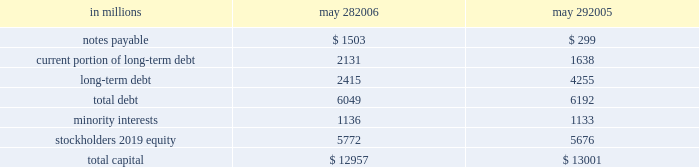During fiscal 2006 , we repurchased 19 million shares of common stock for an aggregate purchase price of $ 892 million , of which $ 7 million settled after the end of our fiscal year .
In fiscal 2005 , we repurchased 17 million shares of common stock for an aggregate purchase price of $ 771 million .
A total of 146 million shares were held in treasury at may 28 , 2006 .
We also used cash from operations to repay $ 189 million in outstanding debt in fiscal 2006 .
In fiscal 2005 , we repaid nearly $ 2.2 billion of debt , including the purchase of $ 760 million principal amount of our 6 percent notes due in 2012 .
Fiscal 2005 debt repurchase costs were $ 137 million , consisting of $ 73 million of noncash interest rate swap losses reclassified from accumulated other comprehen- sive income , $ 59 million of purchase premium and $ 5 million of noncash unamortized cost of issuance expense .
Capital structure in millions may 28 , may 29 .
We have $ 2.1 billion of long-term debt maturing in the next 12 months and classified as current , including $ 131 million that may mature in fiscal 2007 based on the put rights of those note holders .
We believe that cash flows from operations , together with available short- and long- term debt financing , will be adequate to meet our liquidity and capital needs for at least the next 12 months .
On october 28 , 2005 , we repurchased a significant portion of our zero coupon convertible debentures pursuant to put rights of the holders for an aggregate purchase price of $ 1.33 billion , including $ 77 million of accreted original issue discount .
These debentures had an aggregate prin- cipal amount at maturity of $ 1.86 billion .
We incurred no gain or loss from this repurchase .
As of may 28 , 2006 , there were $ 371 million in aggregate principal amount at matu- rity of the debentures outstanding , or $ 268 million of accreted value .
We used proceeds from the issuance of commercial paper to fund the purchase price of the deben- tures .
We also have reclassified the remaining zero coupon convertible debentures to long-term debt based on the october 2008 put rights of the holders .
On march 23 , 2005 , we commenced a cash tender offer for our outstanding 6 percent notes due in 2012 .
The tender offer resulted in the purchase of $ 500 million principal amount of the notes .
Subsequent to the expiration of the tender offer , we purchased an additional $ 260 million prin- cipal amount of the notes in the open market .
The aggregate purchases resulted in the debt repurchase costs as discussed above .
Our minority interests consist of interests in certain of our subsidiaries that are held by third parties .
General mills cereals , llc ( gmc ) , our subsidiary , holds the manufac- turing assets and intellectual property associated with the production and retail sale of big g ready-to-eat cereals , progresso soups and old el paso products .
In may 2002 , one of our wholly owned subsidiaries sold 150000 class a preferred membership interests in gmc to an unrelated third-party investor in exchange for $ 150 million , and in october 2004 , another of our wholly owned subsidiaries sold 835000 series b-1 preferred membership interests in gmc in exchange for $ 835 million .
All interests in gmc , other than the 150000 class a interests and 835000 series b-1 interests , but including all managing member inter- ests , are held by our wholly owned subsidiaries .
In fiscal 2003 , general mills capital , inc .
( gm capital ) , a subsidiary formed for the purpose of purchasing and collecting our receivables , sold $ 150 million of its series a preferred stock to an unrelated third-party investor .
The class a interests of gmc receive quarterly preferred distributions at a floating rate equal to ( i ) the sum of three- month libor plus 90 basis points , divided by ( ii ) 0.965 .
This rate will be adjusted by agreement between the third- party investor holding the class a interests and gmc every five years , beginning in june 2007 .
Under certain circum- stances , gmc also may be required to be dissolved and liquidated , including , without limitation , the bankruptcy of gmc or its subsidiaries , failure to deliver the preferred distributions , failure to comply with portfolio requirements , breaches of certain covenants , lowering of our senior debt rating below either baa3 by moody 2019s or bbb by standard & poor 2019s , and a failed attempt to remarket the class a inter- ests as a result of a breach of gmc 2019s obligations to assist in such remarketing .
In the event of a liquidation of gmc , each member of gmc would receive the amount of its then current capital account balance .
The managing member may avoid liquidation in most circumstances by exercising an option to purchase the class a interests .
The series b-1 interests of gmc are entitled to receive quarterly preferred distributions at a fixed rate of 4.5 percent per year , which is scheduled to be reset to a new fixed rate through a remarketing in october 2007 .
Beginning in october 2007 , the managing member of gmc may elect to repurchase the series b-1 interests for an amount equal to the holder 2019s then current capital account balance plus any applicable make-whole amount .
Gmc is not required to purchase the series b-1 interests nor may these investors put these interests to us .
The series b-1 interests will be exchanged for shares of our perpetual preferred stock upon the occurrence of any of the following events : our senior unsecured debt rating falling below either ba3 as rated by moody 2019s or bb- as rated by standard & poor 2019s or fitch , inc. .
In fiscal 2005 debt repurchase costs what was the of noncash interest rate swap losses reclassified from accumulated other comprehen- sive income involved in the transaction? 
Computations: (73 / 137)
Answer: 0.53285. 